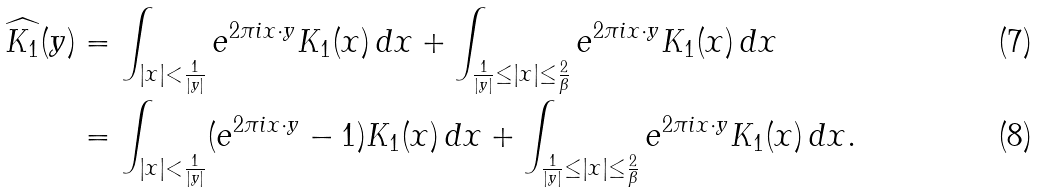<formula> <loc_0><loc_0><loc_500><loc_500>\widehat { K _ { 1 } } ( y ) & = \int _ { | x | < \frac { 1 } { | y | } } e ^ { 2 \pi i x \cdot y } K _ { 1 } ( x ) \, d x + \int _ { \frac { 1 } { | y | } \leq | x | \leq \frac { 2 } { \beta } } e ^ { 2 \pi i x \cdot y } K _ { 1 } ( x ) \, d x \\ & = \int _ { | x | < \frac { 1 } { | y | } } ( e ^ { 2 \pi i x \cdot y } - 1 ) K _ { 1 } ( x ) \, d x + \int _ { \frac { 1 } { | y | } \leq | x | \leq \frac { 2 } { \beta } } e ^ { 2 \pi i x \cdot y } K _ { 1 } ( x ) \, d x .</formula> 